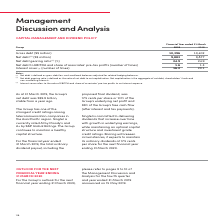According to Singapore Telecommunications's financial document, What was the total ordinary dividend payout per share? 17.5 cents per share. The document states: "proposed ﬁnal dividend, was 17.5 cents per share or 101% of the Group’s underlying net proﬁt and 88% of the Group’s free cash ﬂow (after interest an p..." Also, What is Singtel's credit rating given by Moody's? According to the financial document, A1. The relevant text states: "he Asia Paciﬁc region. Singtel is currently rated A1 by Moody’s and A+ by S&P Global Ratings. The Group continues to maintain a healthy capital structur he Asia Paciﬁc region. Singtel is currently rat..." Also, What is Singtel's credit rating given by S&P Global Ratings? According to the financial document, A+. The relevant text states: "gion. Singtel is currently rated A1 by Moody’s and A+ by S&P Global Ratings. The Group continues to maintain a healthy capital structure. gion. Singtel is currently rated A1 by Moody’s and A+ by S&P G..." Additionally, Which year did Singtel have a higher interest cover? According to the financial document, 2018. The relevant text states: "Financial Year ended 31 March Group 2019 2018..." Also, can you calculate: What is the average gross debt across the 2 years? To answer this question, I need to perform calculations using the financial data. The calculation is: ( 10,396 + 10,402 ) / 2, which equals 10399 (in millions). This is based on the information: "Gross debt (S$ million) 10,396 10,402 Net debt (1) (S$ million) 9,883 9,877 Net debt gearing ratio (2) (%) 24.9 24.9 Net debt to E Gross debt (S$ million) 10,396 10,402 Net debt (1) (S$ million) 9,883..." The key data points involved are: 10,396, 10,402. Also, How many factors need to be considered when calculating net capitalisation? Counting the relevant items in the document: net debt, shareholders’ funds, non-controlling interests, I find 3 instances. The key data points involved are: net debt, non-controlling interests, shareholders’ funds. 